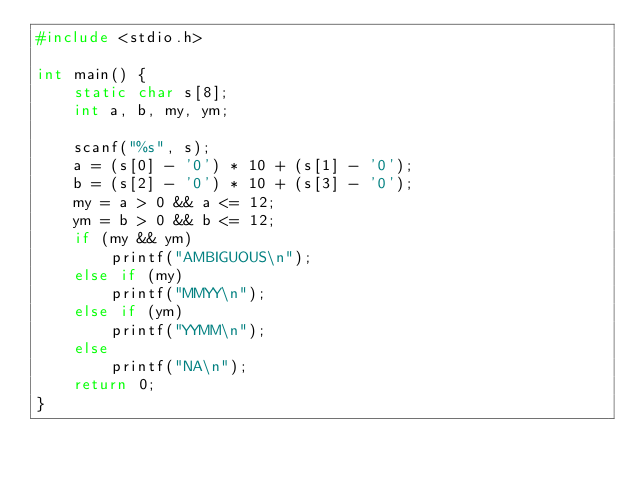<code> <loc_0><loc_0><loc_500><loc_500><_C_>#include <stdio.h>

int main() {
	static char s[8];
	int a, b, my, ym;

	scanf("%s", s);
	a = (s[0] - '0') * 10 + (s[1] - '0');
	b = (s[2] - '0') * 10 + (s[3] - '0');
	my = a > 0 && a <= 12;
	ym = b > 0 && b <= 12;
	if (my && ym)
		printf("AMBIGUOUS\n");
	else if (my)
		printf("MMYY\n");
	else if (ym)
		printf("YYMM\n");
	else
		printf("NA\n");
	return 0;
}
</code> 